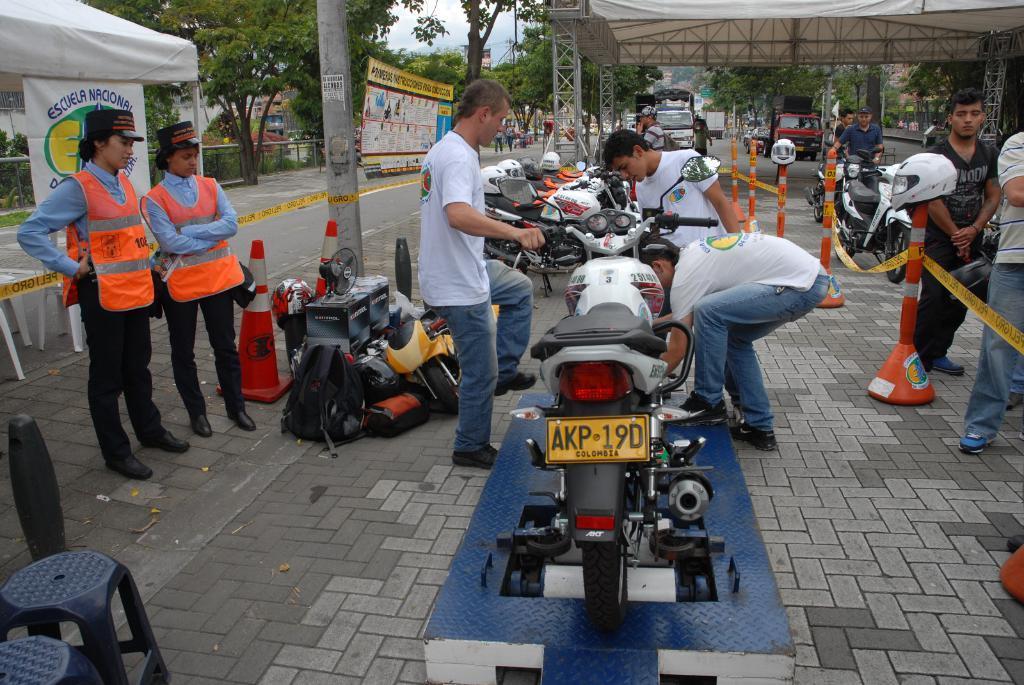Please provide a concise description of this image. Here in this picture we can see motor bikes present over a place and we can see some people repairing it and we can also see helmets present over there and we can see two women on the left side wearing caps and aprons standing over there and we can also see traffic cones present and we can see stools present and we can see some bags present and we can also see a tent present and in the far we can see other vehicles present and we can also see other tents present and we can also see plants and trees present and we can also see banners present and we can see the sky is cloudy. 